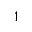<formula> <loc_0><loc_0><loc_500><loc_500>^ { 1 }</formula> 